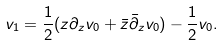<formula> <loc_0><loc_0><loc_500><loc_500>v _ { 1 } = \frac { 1 } { 2 } ( z \partial _ { z } v _ { 0 } + \bar { z } \bar { \partial } _ { z } v _ { 0 } ) - \frac { 1 } { 2 } v _ { 0 } .</formula> 